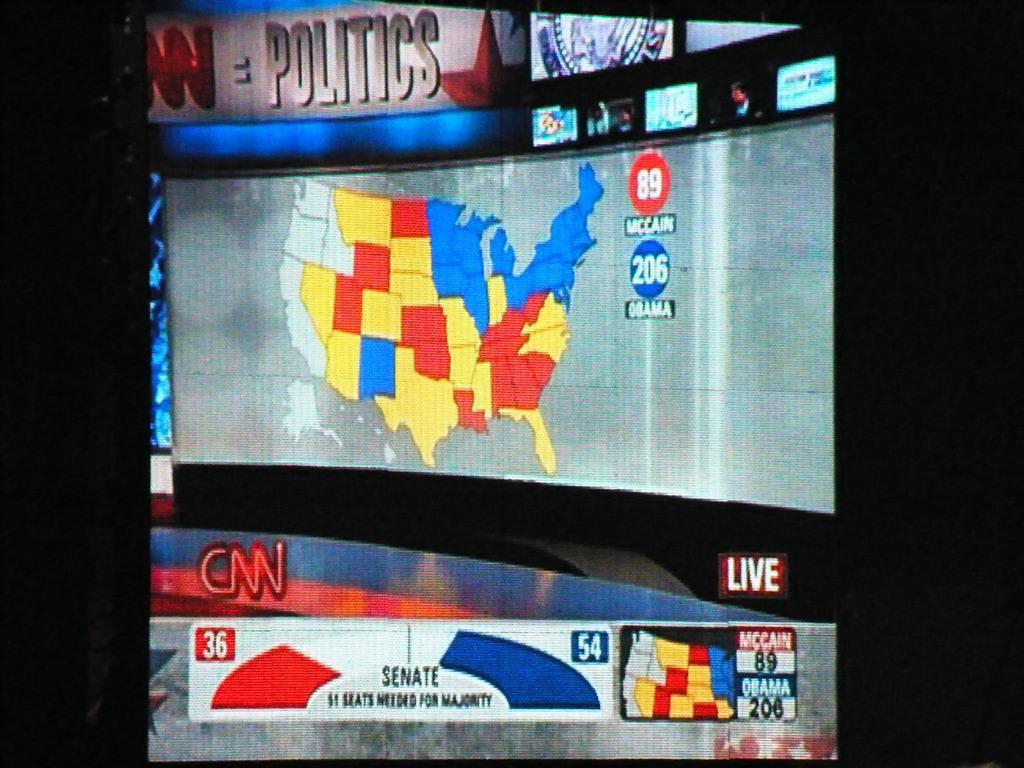<image>
Provide a brief description of the given image. A news room set that says CNN Politics and shows a map of the US on a wall-sized screen. 